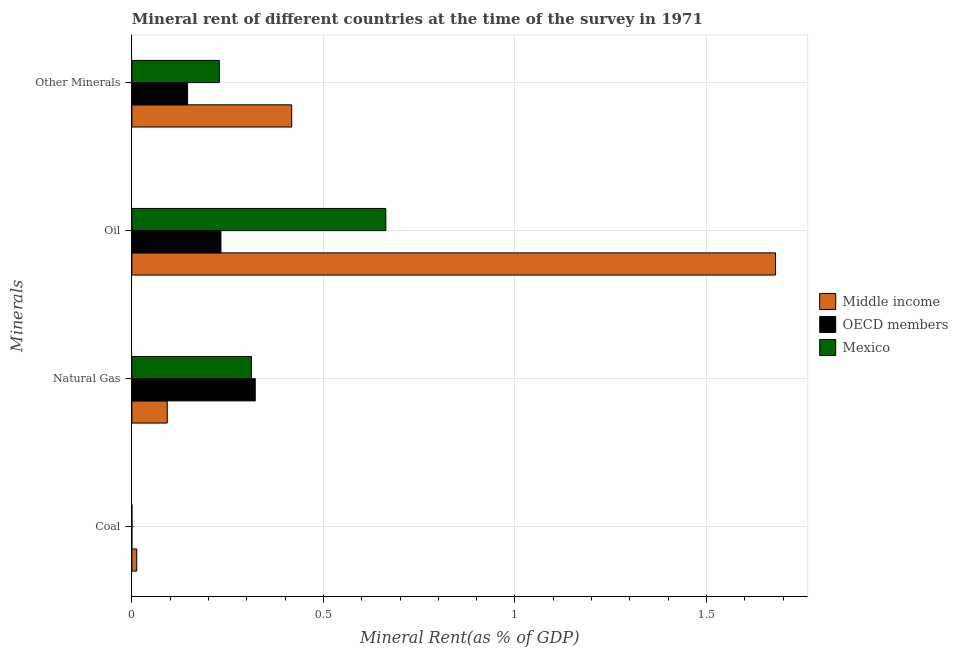Are the number of bars per tick equal to the number of legend labels?
Give a very brief answer. Yes. Are the number of bars on each tick of the Y-axis equal?
Give a very brief answer. Yes. How many bars are there on the 1st tick from the top?
Ensure brevity in your answer.  3. What is the label of the 4th group of bars from the top?
Your response must be concise. Coal. What is the coal rent in Mexico?
Make the answer very short. 0. Across all countries, what is the maximum coal rent?
Give a very brief answer. 0.01. Across all countries, what is the minimum  rent of other minerals?
Give a very brief answer. 0.15. In which country was the coal rent maximum?
Your answer should be compact. Middle income. In which country was the coal rent minimum?
Provide a short and direct response. OECD members. What is the total oil rent in the graph?
Your answer should be compact. 2.58. What is the difference between the coal rent in Middle income and that in Mexico?
Your answer should be very brief. 0.01. What is the difference between the  rent of other minerals in Mexico and the oil rent in OECD members?
Offer a very short reply. -0. What is the average natural gas rent per country?
Make the answer very short. 0.24. What is the difference between the oil rent and natural gas rent in OECD members?
Your response must be concise. -0.09. In how many countries, is the coal rent greater than 1 %?
Provide a short and direct response. 0. What is the ratio of the oil rent in Middle income to that in Mexico?
Provide a short and direct response. 2.53. Is the  rent of other minerals in OECD members less than that in Middle income?
Keep it short and to the point. Yes. Is the difference between the oil rent in OECD members and Middle income greater than the difference between the coal rent in OECD members and Middle income?
Keep it short and to the point. No. What is the difference between the highest and the second highest oil rent?
Your answer should be very brief. 1.02. What is the difference between the highest and the lowest natural gas rent?
Your response must be concise. 0.23. Is the sum of the natural gas rent in Middle income and Mexico greater than the maximum coal rent across all countries?
Make the answer very short. Yes. Is it the case that in every country, the sum of the  rent of other minerals and coal rent is greater than the sum of oil rent and natural gas rent?
Provide a succinct answer. Yes. What does the 1st bar from the top in Natural Gas represents?
Make the answer very short. Mexico. Is it the case that in every country, the sum of the coal rent and natural gas rent is greater than the oil rent?
Your response must be concise. No. Are all the bars in the graph horizontal?
Make the answer very short. Yes. What is the difference between two consecutive major ticks on the X-axis?
Your response must be concise. 0.5. Does the graph contain any zero values?
Your answer should be very brief. No. How many legend labels are there?
Your answer should be very brief. 3. How are the legend labels stacked?
Offer a very short reply. Vertical. What is the title of the graph?
Keep it short and to the point. Mineral rent of different countries at the time of the survey in 1971. Does "United States" appear as one of the legend labels in the graph?
Give a very brief answer. No. What is the label or title of the X-axis?
Make the answer very short. Mineral Rent(as % of GDP). What is the label or title of the Y-axis?
Keep it short and to the point. Minerals. What is the Mineral Rent(as % of GDP) in Middle income in Coal?
Ensure brevity in your answer.  0.01. What is the Mineral Rent(as % of GDP) in OECD members in Coal?
Give a very brief answer. 1.83188177110096e-6. What is the Mineral Rent(as % of GDP) of Mexico in Coal?
Keep it short and to the point. 0. What is the Mineral Rent(as % of GDP) in Middle income in Natural Gas?
Give a very brief answer. 0.09. What is the Mineral Rent(as % of GDP) in OECD members in Natural Gas?
Offer a terse response. 0.32. What is the Mineral Rent(as % of GDP) of Mexico in Natural Gas?
Make the answer very short. 0.31. What is the Mineral Rent(as % of GDP) in Middle income in Oil?
Make the answer very short. 1.68. What is the Mineral Rent(as % of GDP) of OECD members in Oil?
Your answer should be compact. 0.23. What is the Mineral Rent(as % of GDP) in Mexico in Oil?
Ensure brevity in your answer.  0.66. What is the Mineral Rent(as % of GDP) in Middle income in Other Minerals?
Keep it short and to the point. 0.42. What is the Mineral Rent(as % of GDP) of OECD members in Other Minerals?
Offer a terse response. 0.15. What is the Mineral Rent(as % of GDP) in Mexico in Other Minerals?
Provide a short and direct response. 0.23. Across all Minerals, what is the maximum Mineral Rent(as % of GDP) in Middle income?
Ensure brevity in your answer.  1.68. Across all Minerals, what is the maximum Mineral Rent(as % of GDP) in OECD members?
Keep it short and to the point. 0.32. Across all Minerals, what is the maximum Mineral Rent(as % of GDP) of Mexico?
Offer a very short reply. 0.66. Across all Minerals, what is the minimum Mineral Rent(as % of GDP) of Middle income?
Offer a very short reply. 0.01. Across all Minerals, what is the minimum Mineral Rent(as % of GDP) of OECD members?
Your answer should be compact. 1.83188177110096e-6. Across all Minerals, what is the minimum Mineral Rent(as % of GDP) of Mexico?
Ensure brevity in your answer.  0. What is the total Mineral Rent(as % of GDP) in Middle income in the graph?
Ensure brevity in your answer.  2.2. What is the total Mineral Rent(as % of GDP) in Mexico in the graph?
Provide a short and direct response. 1.2. What is the difference between the Mineral Rent(as % of GDP) of Middle income in Coal and that in Natural Gas?
Your response must be concise. -0.08. What is the difference between the Mineral Rent(as % of GDP) in OECD members in Coal and that in Natural Gas?
Ensure brevity in your answer.  -0.32. What is the difference between the Mineral Rent(as % of GDP) in Mexico in Coal and that in Natural Gas?
Offer a terse response. -0.31. What is the difference between the Mineral Rent(as % of GDP) of Middle income in Coal and that in Oil?
Keep it short and to the point. -1.67. What is the difference between the Mineral Rent(as % of GDP) of OECD members in Coal and that in Oil?
Offer a very short reply. -0.23. What is the difference between the Mineral Rent(as % of GDP) in Mexico in Coal and that in Oil?
Provide a succinct answer. -0.66. What is the difference between the Mineral Rent(as % of GDP) in Middle income in Coal and that in Other Minerals?
Provide a short and direct response. -0.4. What is the difference between the Mineral Rent(as % of GDP) in OECD members in Coal and that in Other Minerals?
Provide a short and direct response. -0.15. What is the difference between the Mineral Rent(as % of GDP) of Mexico in Coal and that in Other Minerals?
Provide a succinct answer. -0.23. What is the difference between the Mineral Rent(as % of GDP) in Middle income in Natural Gas and that in Oil?
Your answer should be compact. -1.59. What is the difference between the Mineral Rent(as % of GDP) of OECD members in Natural Gas and that in Oil?
Offer a terse response. 0.09. What is the difference between the Mineral Rent(as % of GDP) in Mexico in Natural Gas and that in Oil?
Provide a succinct answer. -0.35. What is the difference between the Mineral Rent(as % of GDP) of Middle income in Natural Gas and that in Other Minerals?
Provide a succinct answer. -0.32. What is the difference between the Mineral Rent(as % of GDP) of OECD members in Natural Gas and that in Other Minerals?
Your answer should be compact. 0.18. What is the difference between the Mineral Rent(as % of GDP) of Mexico in Natural Gas and that in Other Minerals?
Give a very brief answer. 0.08. What is the difference between the Mineral Rent(as % of GDP) in Middle income in Oil and that in Other Minerals?
Give a very brief answer. 1.26. What is the difference between the Mineral Rent(as % of GDP) in OECD members in Oil and that in Other Minerals?
Keep it short and to the point. 0.09. What is the difference between the Mineral Rent(as % of GDP) of Mexico in Oil and that in Other Minerals?
Provide a short and direct response. 0.43. What is the difference between the Mineral Rent(as % of GDP) in Middle income in Coal and the Mineral Rent(as % of GDP) in OECD members in Natural Gas?
Offer a very short reply. -0.31. What is the difference between the Mineral Rent(as % of GDP) of Middle income in Coal and the Mineral Rent(as % of GDP) of Mexico in Natural Gas?
Offer a terse response. -0.3. What is the difference between the Mineral Rent(as % of GDP) of OECD members in Coal and the Mineral Rent(as % of GDP) of Mexico in Natural Gas?
Provide a succinct answer. -0.31. What is the difference between the Mineral Rent(as % of GDP) of Middle income in Coal and the Mineral Rent(as % of GDP) of OECD members in Oil?
Your response must be concise. -0.22. What is the difference between the Mineral Rent(as % of GDP) in Middle income in Coal and the Mineral Rent(as % of GDP) in Mexico in Oil?
Keep it short and to the point. -0.65. What is the difference between the Mineral Rent(as % of GDP) in OECD members in Coal and the Mineral Rent(as % of GDP) in Mexico in Oil?
Offer a terse response. -0.66. What is the difference between the Mineral Rent(as % of GDP) in Middle income in Coal and the Mineral Rent(as % of GDP) in OECD members in Other Minerals?
Offer a very short reply. -0.13. What is the difference between the Mineral Rent(as % of GDP) of Middle income in Coal and the Mineral Rent(as % of GDP) of Mexico in Other Minerals?
Provide a succinct answer. -0.22. What is the difference between the Mineral Rent(as % of GDP) of OECD members in Coal and the Mineral Rent(as % of GDP) of Mexico in Other Minerals?
Keep it short and to the point. -0.23. What is the difference between the Mineral Rent(as % of GDP) in Middle income in Natural Gas and the Mineral Rent(as % of GDP) in OECD members in Oil?
Provide a short and direct response. -0.14. What is the difference between the Mineral Rent(as % of GDP) in Middle income in Natural Gas and the Mineral Rent(as % of GDP) in Mexico in Oil?
Make the answer very short. -0.57. What is the difference between the Mineral Rent(as % of GDP) of OECD members in Natural Gas and the Mineral Rent(as % of GDP) of Mexico in Oil?
Give a very brief answer. -0.34. What is the difference between the Mineral Rent(as % of GDP) in Middle income in Natural Gas and the Mineral Rent(as % of GDP) in OECD members in Other Minerals?
Offer a very short reply. -0.05. What is the difference between the Mineral Rent(as % of GDP) of Middle income in Natural Gas and the Mineral Rent(as % of GDP) of Mexico in Other Minerals?
Provide a succinct answer. -0.14. What is the difference between the Mineral Rent(as % of GDP) of OECD members in Natural Gas and the Mineral Rent(as % of GDP) of Mexico in Other Minerals?
Provide a succinct answer. 0.09. What is the difference between the Mineral Rent(as % of GDP) of Middle income in Oil and the Mineral Rent(as % of GDP) of OECD members in Other Minerals?
Ensure brevity in your answer.  1.53. What is the difference between the Mineral Rent(as % of GDP) of Middle income in Oil and the Mineral Rent(as % of GDP) of Mexico in Other Minerals?
Offer a very short reply. 1.45. What is the difference between the Mineral Rent(as % of GDP) in OECD members in Oil and the Mineral Rent(as % of GDP) in Mexico in Other Minerals?
Your response must be concise. 0. What is the average Mineral Rent(as % of GDP) of Middle income per Minerals?
Your answer should be compact. 0.55. What is the average Mineral Rent(as % of GDP) of OECD members per Minerals?
Your response must be concise. 0.17. What is the average Mineral Rent(as % of GDP) in Mexico per Minerals?
Ensure brevity in your answer.  0.3. What is the difference between the Mineral Rent(as % of GDP) of Middle income and Mineral Rent(as % of GDP) of OECD members in Coal?
Make the answer very short. 0.01. What is the difference between the Mineral Rent(as % of GDP) in Middle income and Mineral Rent(as % of GDP) in Mexico in Coal?
Make the answer very short. 0.01. What is the difference between the Mineral Rent(as % of GDP) of OECD members and Mineral Rent(as % of GDP) of Mexico in Coal?
Offer a terse response. -0. What is the difference between the Mineral Rent(as % of GDP) in Middle income and Mineral Rent(as % of GDP) in OECD members in Natural Gas?
Your response must be concise. -0.23. What is the difference between the Mineral Rent(as % of GDP) in Middle income and Mineral Rent(as % of GDP) in Mexico in Natural Gas?
Provide a succinct answer. -0.22. What is the difference between the Mineral Rent(as % of GDP) of Middle income and Mineral Rent(as % of GDP) of OECD members in Oil?
Provide a short and direct response. 1.45. What is the difference between the Mineral Rent(as % of GDP) of Middle income and Mineral Rent(as % of GDP) of Mexico in Oil?
Your answer should be compact. 1.02. What is the difference between the Mineral Rent(as % of GDP) in OECD members and Mineral Rent(as % of GDP) in Mexico in Oil?
Offer a terse response. -0.43. What is the difference between the Mineral Rent(as % of GDP) of Middle income and Mineral Rent(as % of GDP) of OECD members in Other Minerals?
Your answer should be compact. 0.27. What is the difference between the Mineral Rent(as % of GDP) in Middle income and Mineral Rent(as % of GDP) in Mexico in Other Minerals?
Make the answer very short. 0.19. What is the difference between the Mineral Rent(as % of GDP) of OECD members and Mineral Rent(as % of GDP) of Mexico in Other Minerals?
Offer a very short reply. -0.08. What is the ratio of the Mineral Rent(as % of GDP) of Middle income in Coal to that in Natural Gas?
Your answer should be very brief. 0.14. What is the ratio of the Mineral Rent(as % of GDP) of Middle income in Coal to that in Oil?
Make the answer very short. 0.01. What is the ratio of the Mineral Rent(as % of GDP) in Middle income in Coal to that in Other Minerals?
Your answer should be very brief. 0.03. What is the ratio of the Mineral Rent(as % of GDP) of OECD members in Coal to that in Other Minerals?
Keep it short and to the point. 0. What is the ratio of the Mineral Rent(as % of GDP) in Mexico in Coal to that in Other Minerals?
Your answer should be very brief. 0. What is the ratio of the Mineral Rent(as % of GDP) of Middle income in Natural Gas to that in Oil?
Keep it short and to the point. 0.06. What is the ratio of the Mineral Rent(as % of GDP) of OECD members in Natural Gas to that in Oil?
Provide a succinct answer. 1.39. What is the ratio of the Mineral Rent(as % of GDP) of Mexico in Natural Gas to that in Oil?
Your answer should be compact. 0.47. What is the ratio of the Mineral Rent(as % of GDP) in Middle income in Natural Gas to that in Other Minerals?
Your response must be concise. 0.22. What is the ratio of the Mineral Rent(as % of GDP) of OECD members in Natural Gas to that in Other Minerals?
Ensure brevity in your answer.  2.21. What is the ratio of the Mineral Rent(as % of GDP) in Mexico in Natural Gas to that in Other Minerals?
Your response must be concise. 1.37. What is the ratio of the Mineral Rent(as % of GDP) in Middle income in Oil to that in Other Minerals?
Offer a very short reply. 4.03. What is the ratio of the Mineral Rent(as % of GDP) in OECD members in Oil to that in Other Minerals?
Keep it short and to the point. 1.6. What is the ratio of the Mineral Rent(as % of GDP) of Mexico in Oil to that in Other Minerals?
Your answer should be very brief. 2.9. What is the difference between the highest and the second highest Mineral Rent(as % of GDP) of Middle income?
Make the answer very short. 1.26. What is the difference between the highest and the second highest Mineral Rent(as % of GDP) of OECD members?
Keep it short and to the point. 0.09. What is the difference between the highest and the second highest Mineral Rent(as % of GDP) of Mexico?
Provide a succinct answer. 0.35. What is the difference between the highest and the lowest Mineral Rent(as % of GDP) in Middle income?
Provide a short and direct response. 1.67. What is the difference between the highest and the lowest Mineral Rent(as % of GDP) of OECD members?
Keep it short and to the point. 0.32. What is the difference between the highest and the lowest Mineral Rent(as % of GDP) of Mexico?
Keep it short and to the point. 0.66. 